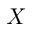<formula> <loc_0><loc_0><loc_500><loc_500>X</formula> 